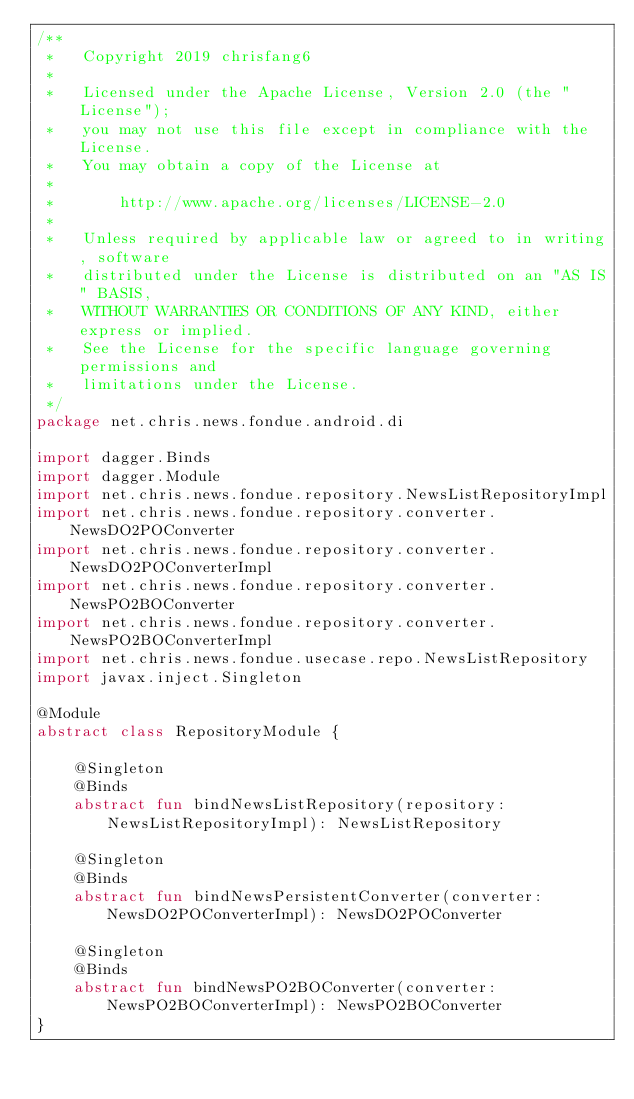Convert code to text. <code><loc_0><loc_0><loc_500><loc_500><_Kotlin_>/**
 *   Copyright 2019 chrisfang6
 *
 *   Licensed under the Apache License, Version 2.0 (the "License");
 *   you may not use this file except in compliance with the License.
 *   You may obtain a copy of the License at
 *
 *       http://www.apache.org/licenses/LICENSE-2.0
 *
 *   Unless required by applicable law or agreed to in writing, software
 *   distributed under the License is distributed on an "AS IS" BASIS,
 *   WITHOUT WARRANTIES OR CONDITIONS OF ANY KIND, either express or implied.
 *   See the License for the specific language governing permissions and
 *   limitations under the License.
 */
package net.chris.news.fondue.android.di

import dagger.Binds
import dagger.Module
import net.chris.news.fondue.repository.NewsListRepositoryImpl
import net.chris.news.fondue.repository.converter.NewsDO2POConverter
import net.chris.news.fondue.repository.converter.NewsDO2POConverterImpl
import net.chris.news.fondue.repository.converter.NewsPO2BOConverter
import net.chris.news.fondue.repository.converter.NewsPO2BOConverterImpl
import net.chris.news.fondue.usecase.repo.NewsListRepository
import javax.inject.Singleton

@Module
abstract class RepositoryModule {

    @Singleton
    @Binds
    abstract fun bindNewsListRepository(repository: NewsListRepositoryImpl): NewsListRepository

    @Singleton
    @Binds
    abstract fun bindNewsPersistentConverter(converter: NewsDO2POConverterImpl): NewsDO2POConverter

    @Singleton
    @Binds
    abstract fun bindNewsPO2BOConverter(converter: NewsPO2BOConverterImpl): NewsPO2BOConverter
}
</code> 